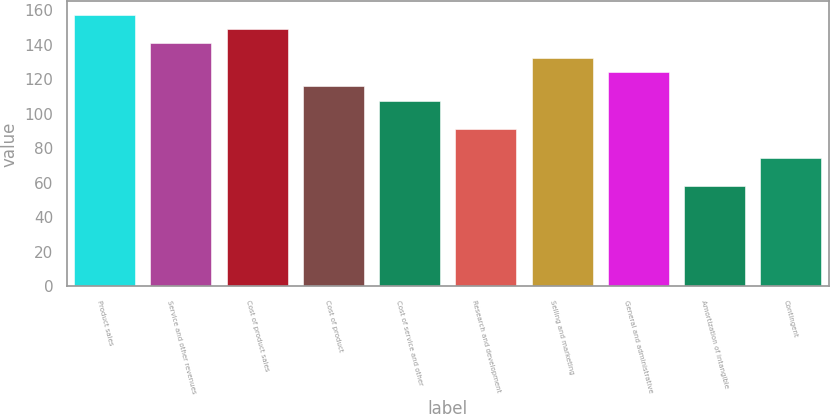<chart> <loc_0><loc_0><loc_500><loc_500><bar_chart><fcel>Product sales<fcel>Service and other revenues<fcel>Cost of product sales<fcel>Cost of product<fcel>Cost of service and other<fcel>Research and development<fcel>Selling and marketing<fcel>General and administrative<fcel>Amortization of intangible<fcel>Contingent<nl><fcel>157.23<fcel>140.69<fcel>148.96<fcel>115.88<fcel>107.61<fcel>91.07<fcel>132.42<fcel>124.15<fcel>57.99<fcel>74.53<nl></chart> 